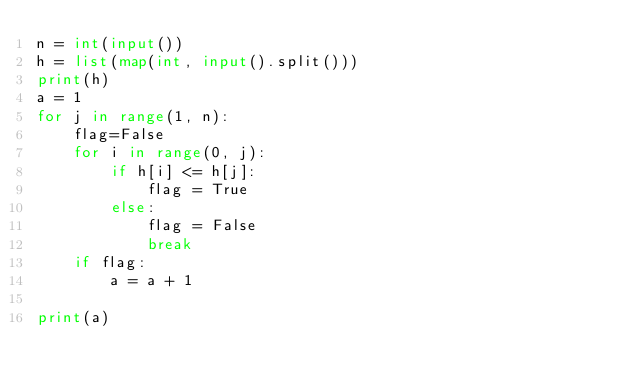Convert code to text. <code><loc_0><loc_0><loc_500><loc_500><_Python_>n = int(input())
h = list(map(int, input().split()))
print(h)
a = 1
for j in range(1, n):
    flag=False
    for i in range(0, j):
        if h[i] <= h[j]:
            flag = True
        else:
            flag = False
            break
    if flag:
        a = a + 1

print(a)</code> 